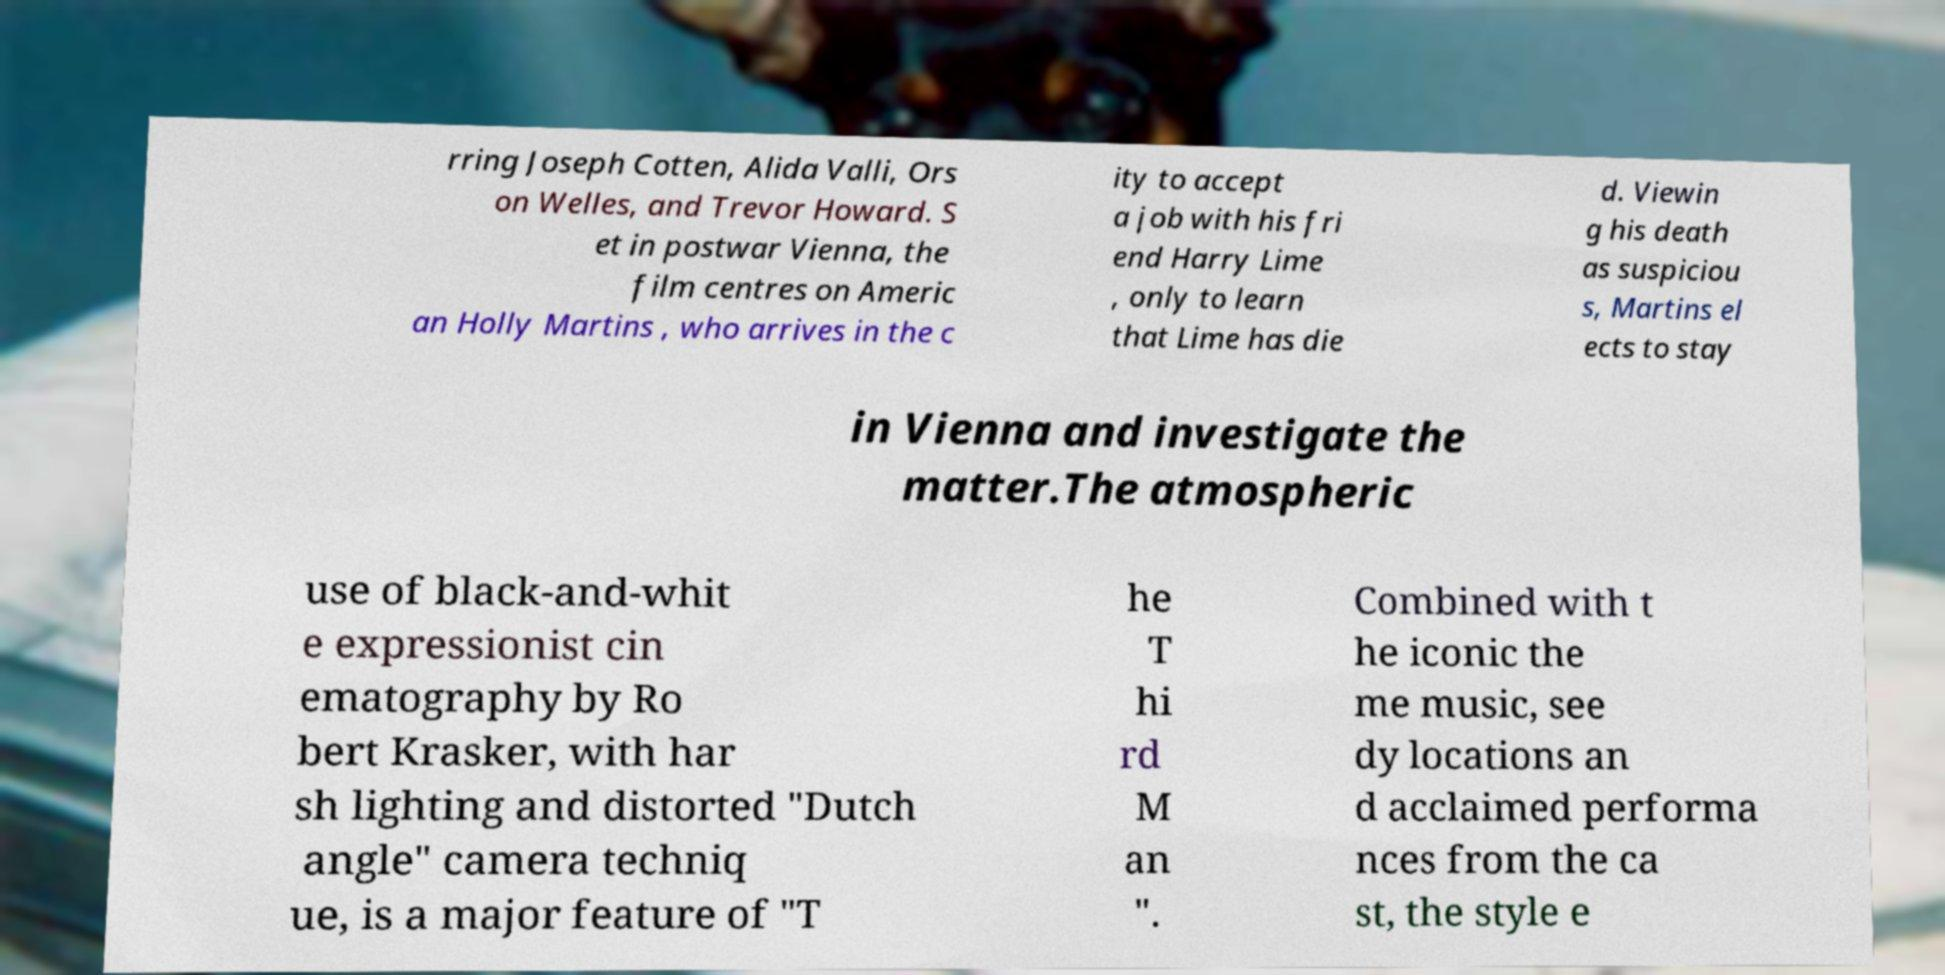I need the written content from this picture converted into text. Can you do that? rring Joseph Cotten, Alida Valli, Ors on Welles, and Trevor Howard. S et in postwar Vienna, the film centres on Americ an Holly Martins , who arrives in the c ity to accept a job with his fri end Harry Lime , only to learn that Lime has die d. Viewin g his death as suspiciou s, Martins el ects to stay in Vienna and investigate the matter.The atmospheric use of black-and-whit e expressionist cin ematography by Ro bert Krasker, with har sh lighting and distorted "Dutch angle" camera techniq ue, is a major feature of "T he T hi rd M an ". Combined with t he iconic the me music, see dy locations an d acclaimed performa nces from the ca st, the style e 